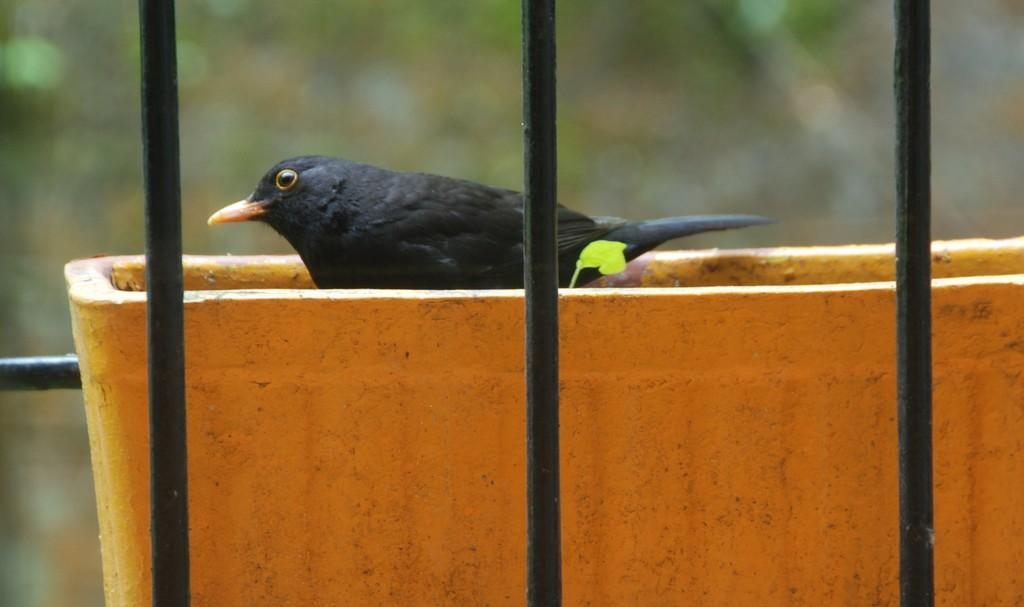What type of animal is in the image? There is a black bird in the image. Where is the bird located in the image? The bird is standing in a tub. What type of punishment is the bird receiving in the image? There is no indication in the image that the bird is receiving any punishment. 